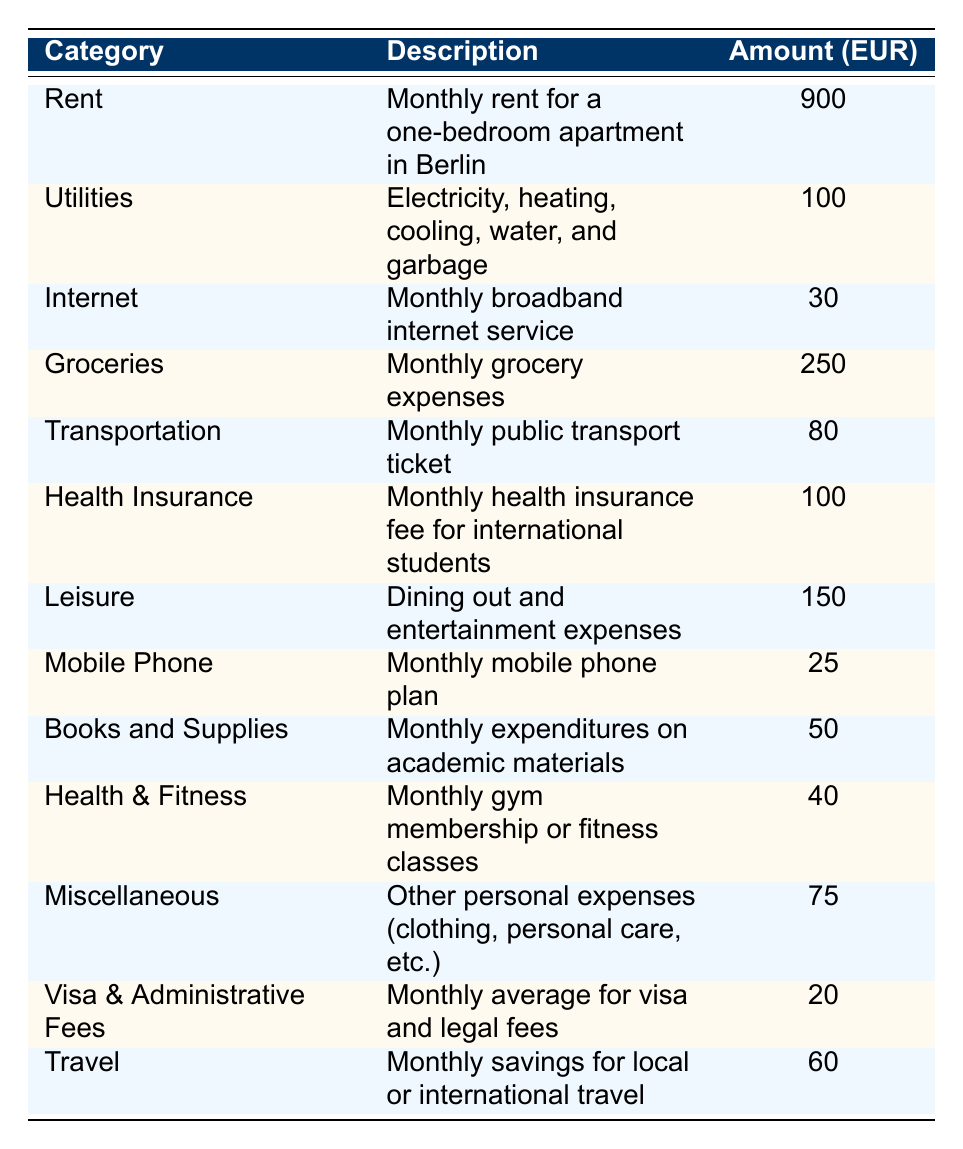What is the total monthly expense for groceries? The table lists the monthly expense for groceries as 250 EUR. Therefore, the total monthly expense for groceries is directly referenced from the table.
Answer: 250 EUR What is the total amount for Rent and Utilities combined? To find the combined total, add the amounts for Rent (900 EUR) and Utilities (100 EUR): 900 + 100 = 1000 EUR.
Answer: 1000 EUR Is the monthly expense for internet less than the one for transportation? The monthly expense for internet is 30 EUR and for transportation is 80 EUR. Since 30 is less than 80, the statement is true.
Answer: Yes What is the total monthly expense for Health Insurance, Leisure, and Travel? The amounts for Health Insurance (100 EUR), Leisure (150 EUR), and Travel (60 EUR) need to be summed: 100 + 150 + 60 = 310 EUR. So, the total monthly expense for these categories is 310 EUR.
Answer: 310 EUR Which category has the highest expense? By examining the table, the Rent category shows an expense of 900 EUR, which is higher than all other amounts listed. Therefore, Rent has the highest expense.
Answer: Rent What is the average monthly expense across all categories listed? To calculate the average, first sum up all the expenses: 900 + 100 + 30 + 250 + 80 + 100 + 150 + 25 + 50 + 40 + 75 + 20 + 60 = 1860 EUR. There are 13 categories, so the average is 1860 / 13 ≈ 143.08 EUR.
Answer: 143.08 EUR Are the monthly expenses for Utilities and Health Insurance equal? The Utilities expense is 100 EUR and the Health Insurance expense is also 100 EUR. Since both values are the same, the answer is true.
Answer: Yes What is the total monthly expense for Mobile Phone, Books and Supplies, and Health & Fitness combined? The combined expenses are calculated as follows: Mobile Phone (25 EUR) + Books and Supplies (50 EUR) + Health & Fitness (40 EUR) = 25 + 50 + 40 = 115 EUR.
Answer: 115 EUR How much more is spent on Leisure than on Miscellaneous? The amount for Leisure is 150 EUR and for Miscellaneous is 75 EUR. The difference is calculated as 150 - 75 = 75 EUR, indicating that Leisure expenses are 75 EUR more than Miscellaneous.
Answer: 75 EUR What percentage of the total monthly expenses does Transportation represent? Total monthly expenses were computed earlier as 1860 EUR. The Transportation expense is 80 EUR. Now, calculate the percentage: (80 / 1860) * 100 ≈ 4.30%. Thus, Transportation makes up approximately 4.30% of total expenses.
Answer: 4.30% If a student saves 60 EUR monthly for travel, how much will they have in a year? Since the student saves 60 EUR each month, in a year (12 months), they will have: 60 * 12 = 720 EUR saved for travel.
Answer: 720 EUR 